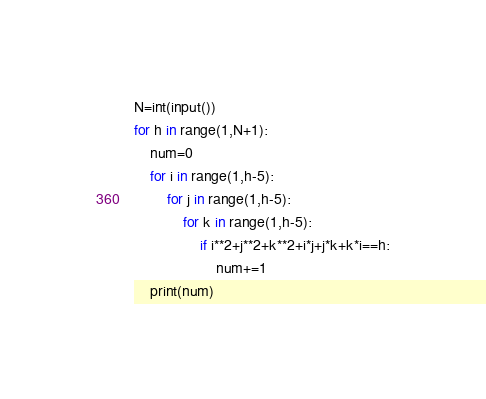Convert code to text. <code><loc_0><loc_0><loc_500><loc_500><_Python_>N=int(input())
for h in range(1,N+1):
    num=0
    for i in range(1,h-5):
        for j in range(1,h-5):
            for k in range(1,h-5):
                if i**2+j**2+k**2+i*j+j*k+k*i==h:
                    num+=1
    print(num)</code> 